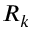<formula> <loc_0><loc_0><loc_500><loc_500>R _ { k }</formula> 